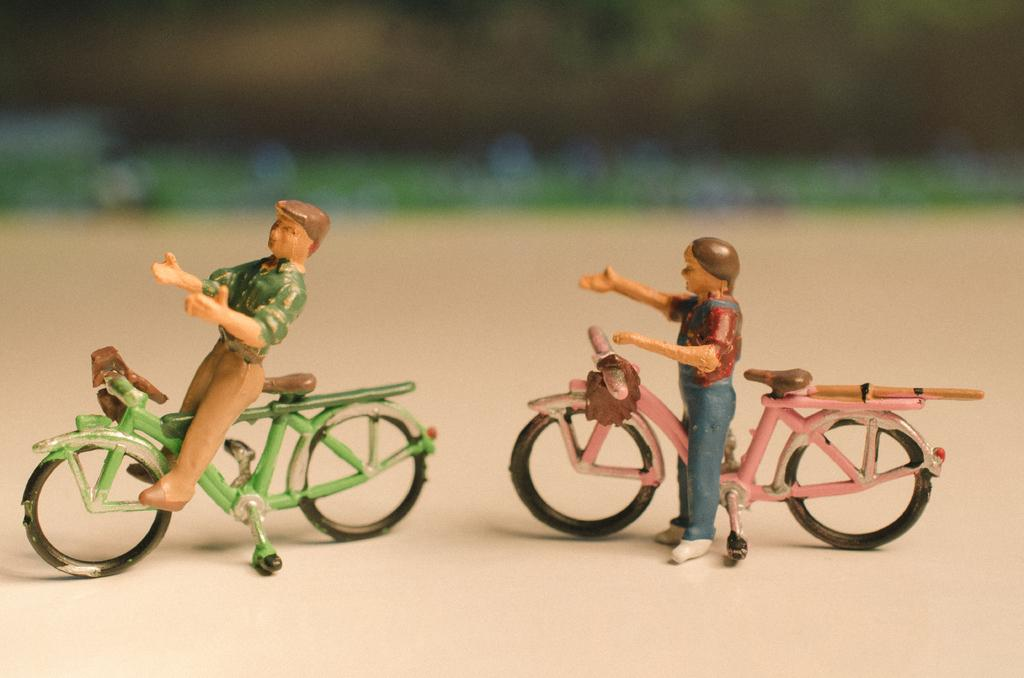What types of toys are in the image? There are two toys in the image, one of a man and a bicycle. What are the toys placed on? The toys are placed on a table. How many cherries are on the brother's bicycle in the image? There is no brother or cherries present in the image. The toys in the image are a man and a bicycle, and they are not associated with a brother or cherries. 